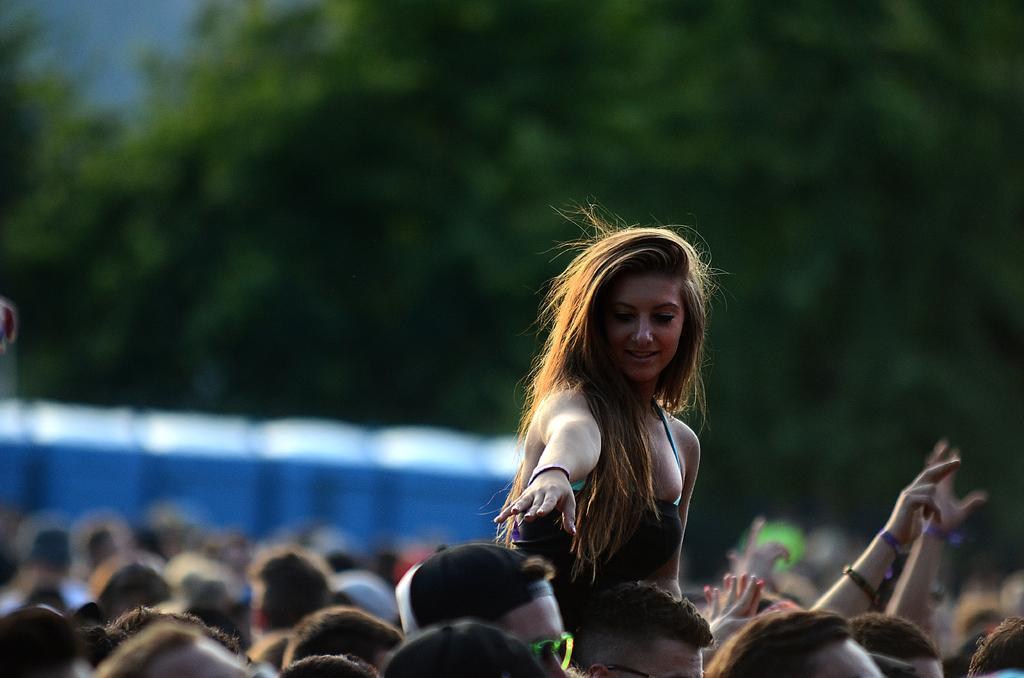What is depicted at the bottom of the image? There are heads of many people at the bottom of the image. Can you describe the lady standing in the image? There is a lady standing in between the people. How would you describe the background of the image? The background of the image is blurred. What can be seen in the blurred background? Trees and blue color objects are visible in the background. How many parcels are being delivered by the lady in the image? There is no lady delivering parcels in the image; she is simply standing in between the people. What type of box is being used to store the tree in the image? There is no tree or box present in the image. 